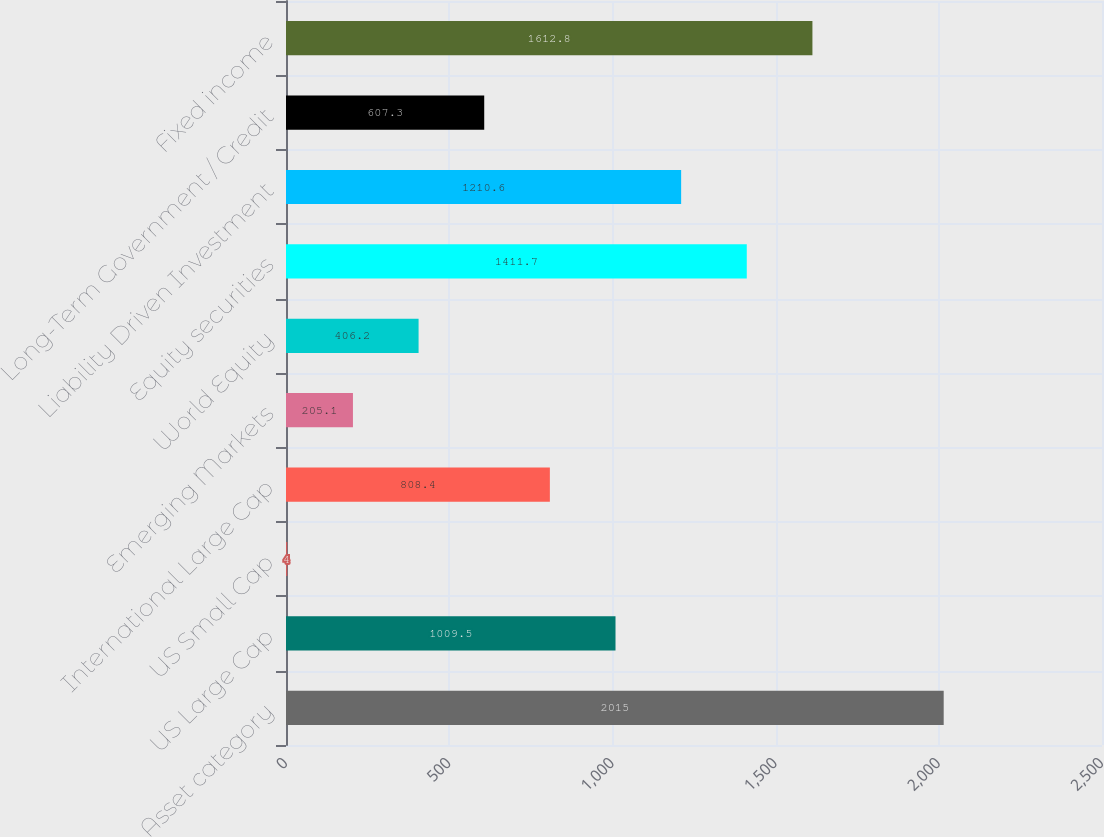Convert chart to OTSL. <chart><loc_0><loc_0><loc_500><loc_500><bar_chart><fcel>Asset category<fcel>US Large Cap<fcel>US Small Cap<fcel>International Large Cap<fcel>Emerging Markets<fcel>World Equity<fcel>Equity securities<fcel>Liability Driven Investment<fcel>Long-Term Government / Credit<fcel>Fixed income<nl><fcel>2015<fcel>1009.5<fcel>4<fcel>808.4<fcel>205.1<fcel>406.2<fcel>1411.7<fcel>1210.6<fcel>607.3<fcel>1612.8<nl></chart> 